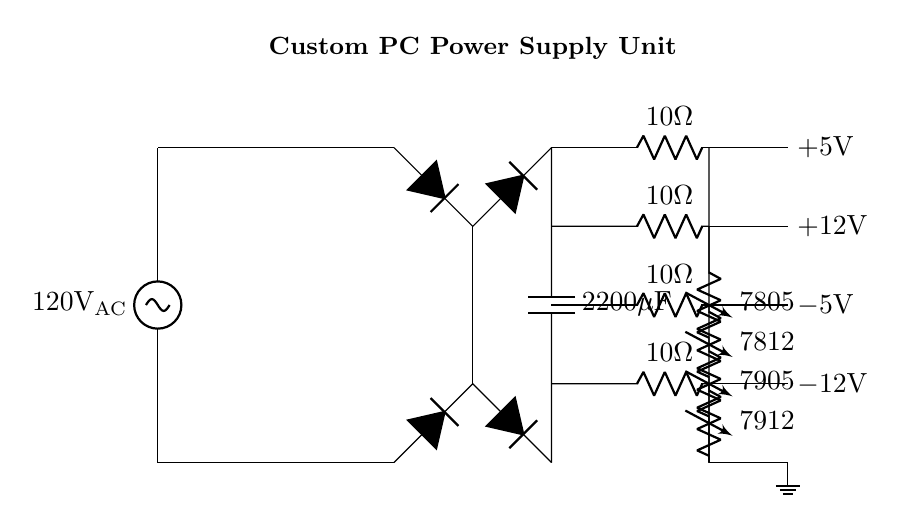What is the main input voltage for the power supply? The main AC input voltage is 120 volts, as indicated at the start of the circuit diagram where it states 120 volts AC.
Answer: 120 volts What type of component is used to convert AC to DC? A bridge rectifier is used for this conversion, which is a specific arrangement of diodes that allows current to pass through in one direction after rectification. This is visible in the section where the diagram shows diodes arranged in a bridge configuration.
Answer: Bridge rectifier How many distinct voltage outputs does the power supply provide? The power supply provides four distinct voltage outputs, as indicated by the different voltage regulators connected to various points in the circuit, specifically 5 volts, 12 volts, -5 volts, and -12 volts.
Answer: Four What is the value of the smoothing capacitor? The smoothing capacitor has a value of 2200 microfarads, which can be seen in the circuit next to the rectifier section and is essential for reducing ripple in the DC output.
Answer: 2200 microfarads Which voltage regulator is used for generating a negative 12 volts output? The voltage regulator labeled 7912 is responsible for generating the negative 12 volts output, as shown in the circuit by its label and connection to the negative voltage branch.
Answer: 7912 What is the resistance value of the series resistors used before the voltage regulators? Each series resistor has a value of 10 ohms, which is indicated on the diagram next to each resistor symbol leading to the voltage regulators.
Answer: 10 ohms What component type is indicated for smoothing the output from the rectifier? A capacitor is indicated for smoothing the output, as seen by the capacitance value directly after the bridge rectifier in the circuit layout. This component helps in stabilizing the output voltage by filtering out fluctuations.
Answer: Capacitor 